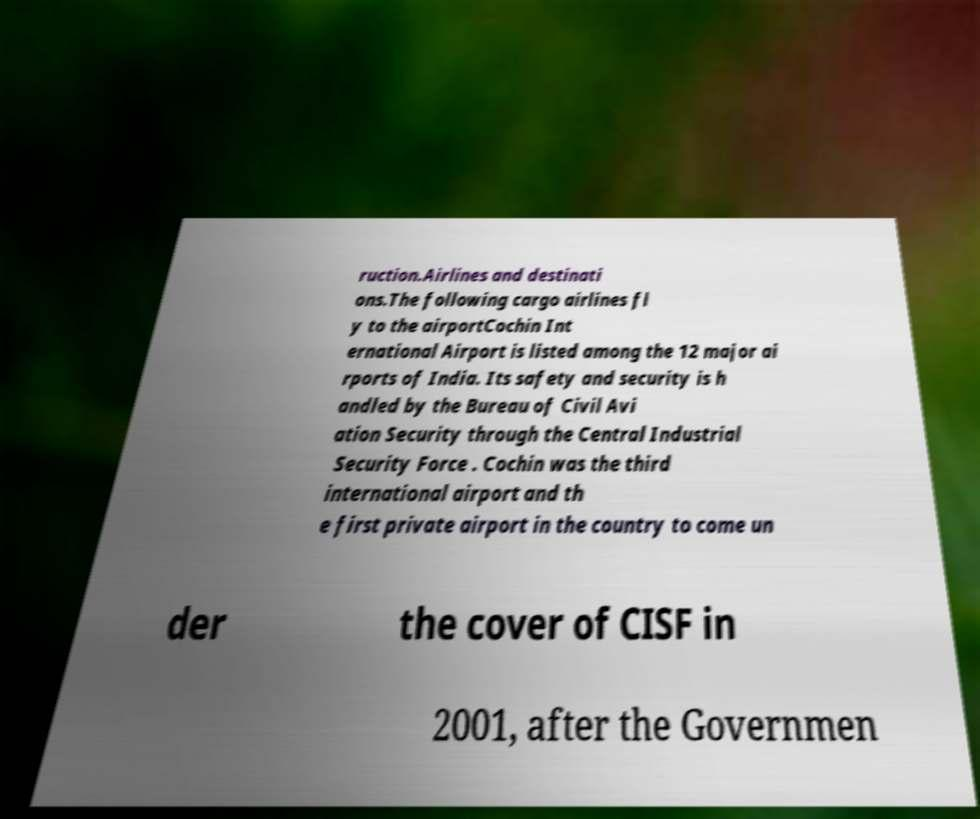I need the written content from this picture converted into text. Can you do that? ruction.Airlines and destinati ons.The following cargo airlines fl y to the airportCochin Int ernational Airport is listed among the 12 major ai rports of India. Its safety and security is h andled by the Bureau of Civil Avi ation Security through the Central Industrial Security Force . Cochin was the third international airport and th e first private airport in the country to come un der the cover of CISF in 2001, after the Governmen 